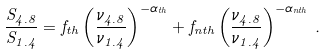Convert formula to latex. <formula><loc_0><loc_0><loc_500><loc_500>\frac { S _ { 4 . 8 } } { S _ { 1 . 4 } } = f _ { t h } \left ( \frac { \nu _ { 4 . 8 } } { \nu _ { 1 . 4 } } \right ) ^ { - \alpha _ { t h } } + f _ { n t h } \left ( \frac { \nu _ { 4 . 8 } } { \nu _ { 1 . 4 } } \right ) ^ { - \alpha _ { n t h } } \, .</formula> 